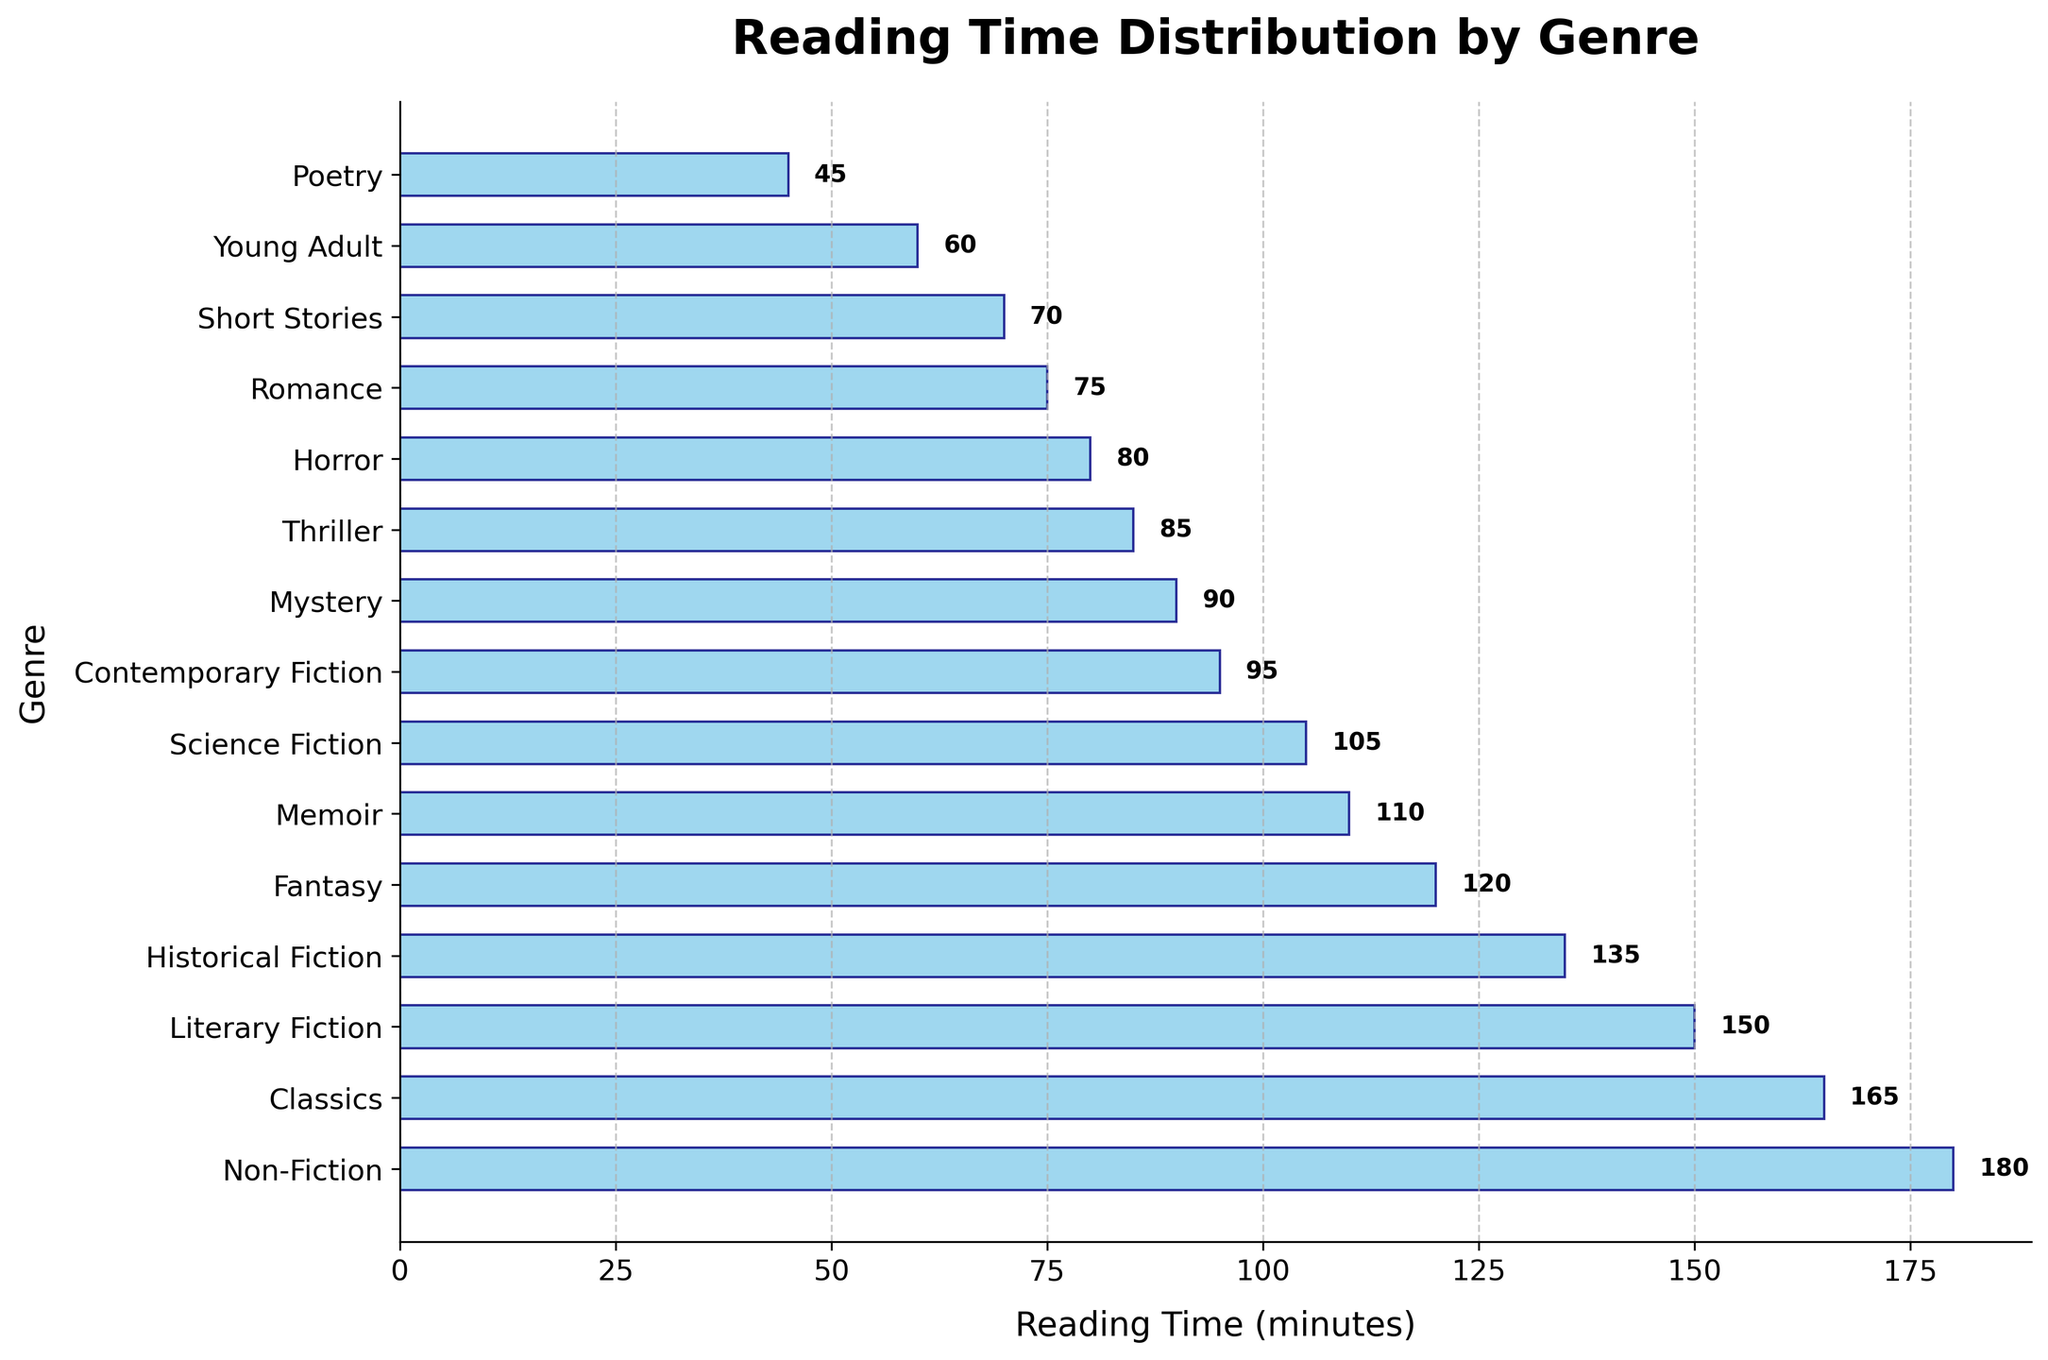What's the title of the figure? The title of the figure is displayed at the top and reads: 'Reading Time Distribution by Genre'.
Answer: Reading Time Distribution by Genre What is the genre with the highest reading time? The genre with the highest reading time is at the top of the horizontal bar chart. This genre is 'Non-Fiction'.
Answer: Non-Fiction How many genres have a reading time above 100 minutes? To find how many genres have a reading time above 100 minutes, count all the bars that extend beyond the 100-minute mark. The genres are Fantasy, Science Fiction, Literary Fiction, Historical Fiction, Memoir, Classics, and Non-Fiction, which totals 7.
Answer: 7 Which genre has the shortest reading time? The genre with the shortest reading time is at the bottom of the horizontal bar chart. This genre is 'Poetry'.
Answer: Poetry What's the total reading time for 'Fantasy' and 'Thriller'? To find the total reading time for 'Fantasy' and 'Thriller', add their reading times together. Fantasy has 120 minutes and Thriller has 85 minutes, so the total is 120 + 85 = 205 minutes.
Answer: 205 Which genre takes more time to read, 'Historical Fiction' or 'Science Fiction'? To determine which takes more time, compare the reading times. Historical Fiction is 135 minutes, and Science Fiction is 105 minutes. Historical Fiction takes more time.
Answer: Historical Fiction What is the average reading time of all genres? To calculate the average reading time, sum all the reading times and divide by the number of genres. The total sum is: 120 + 105 + 90 + 150 + 75 + 85 + 135 + 60 + 180 + 45 + 110 + 70 + 95 + 165 + 80 = 1565. There are 15 genres, so average is 1565/15 = ~104.33 minutes.
Answer: ~104.33 minutes Is the reading time for 'Classics' closer to 'Literary Fiction' or 'Non-Fiction'? Comparing the reading times: Classics is 165 minutes, Literary Fiction is 150 minutes, and Non-Fiction is 180 minutes. The difference from Classics to Literary Fiction is 15 minutes, and to Non-Fiction is also 15 minutes. They are equally close to Classics.
Answer: Equally close Which genres fall below the average reading time? The average reading time is ~104.33 minutes. The genres with reading times below this are Mystery (90), Romance (75), Thriller (85), Young Adult (60), Poetry (45), Short Stories (70), Contemporary Fiction (95), and Horror (80).
Answer: Mystery, Romance, Thriller, Young Adult, Poetry, Short Stories, Contemporary Fiction, Horror 